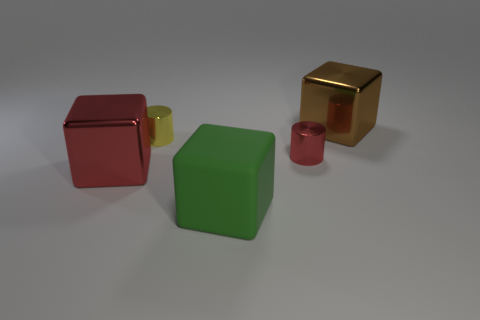Are there any yellow objects that have the same material as the big brown thing?
Your answer should be very brief. Yes. Are there fewer big brown things that are in front of the small red metallic cylinder than small yellow balls?
Ensure brevity in your answer.  No. Do the shiny cube on the right side of the green cube and the red shiny cylinder have the same size?
Your response must be concise. No. How many large brown metallic objects are the same shape as the green rubber thing?
Your answer should be very brief. 1. There is a cube that is the same material as the big brown thing; what size is it?
Your response must be concise. Large. Is the number of small metal cylinders behind the big brown thing the same as the number of shiny cylinders?
Your response must be concise. No. There is a big object that is in front of the big red thing; is its shape the same as the tiny metallic thing on the right side of the green rubber object?
Your answer should be compact. No. There is a green thing that is the same shape as the big red object; what is its material?
Your response must be concise. Rubber. The thing that is both to the left of the large rubber object and behind the small red object is what color?
Provide a succinct answer. Yellow. There is a big brown thing to the right of the small object in front of the tiny yellow cylinder; is there a big object behind it?
Your response must be concise. No. 